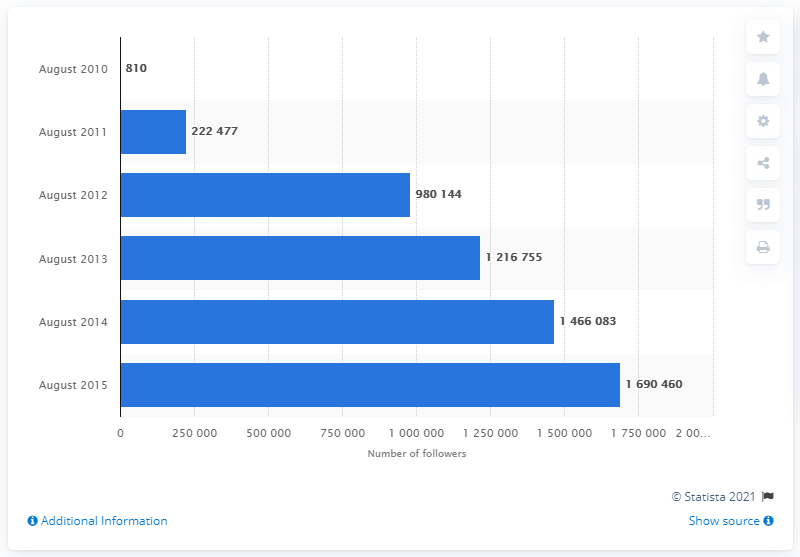Point out several critical features in this image. In August 2010, Tesco had 810 followers on its Facebook page. In August 2015, Tesco had a total of 1690460 followers on Facebook. 